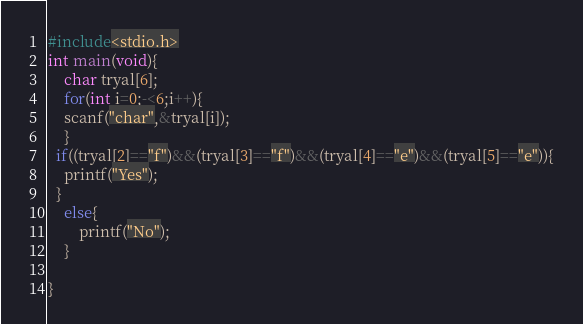Convert code to text. <code><loc_0><loc_0><loc_500><loc_500><_C_>#include<stdio.h>
int main(void){
  	char tryal[6];
  	for(int i=0;-<6;i++){
  	scanf("char",&tryal[i]);
    }
  if((tryal[2]=="f")&&(tryal[3]=="f")&&(tryal[4]=="e")&&(tryal[5]=="e")){
  	printf("Yes");
  }
  	else{
    	printf("No");
    }
  
}
</code> 